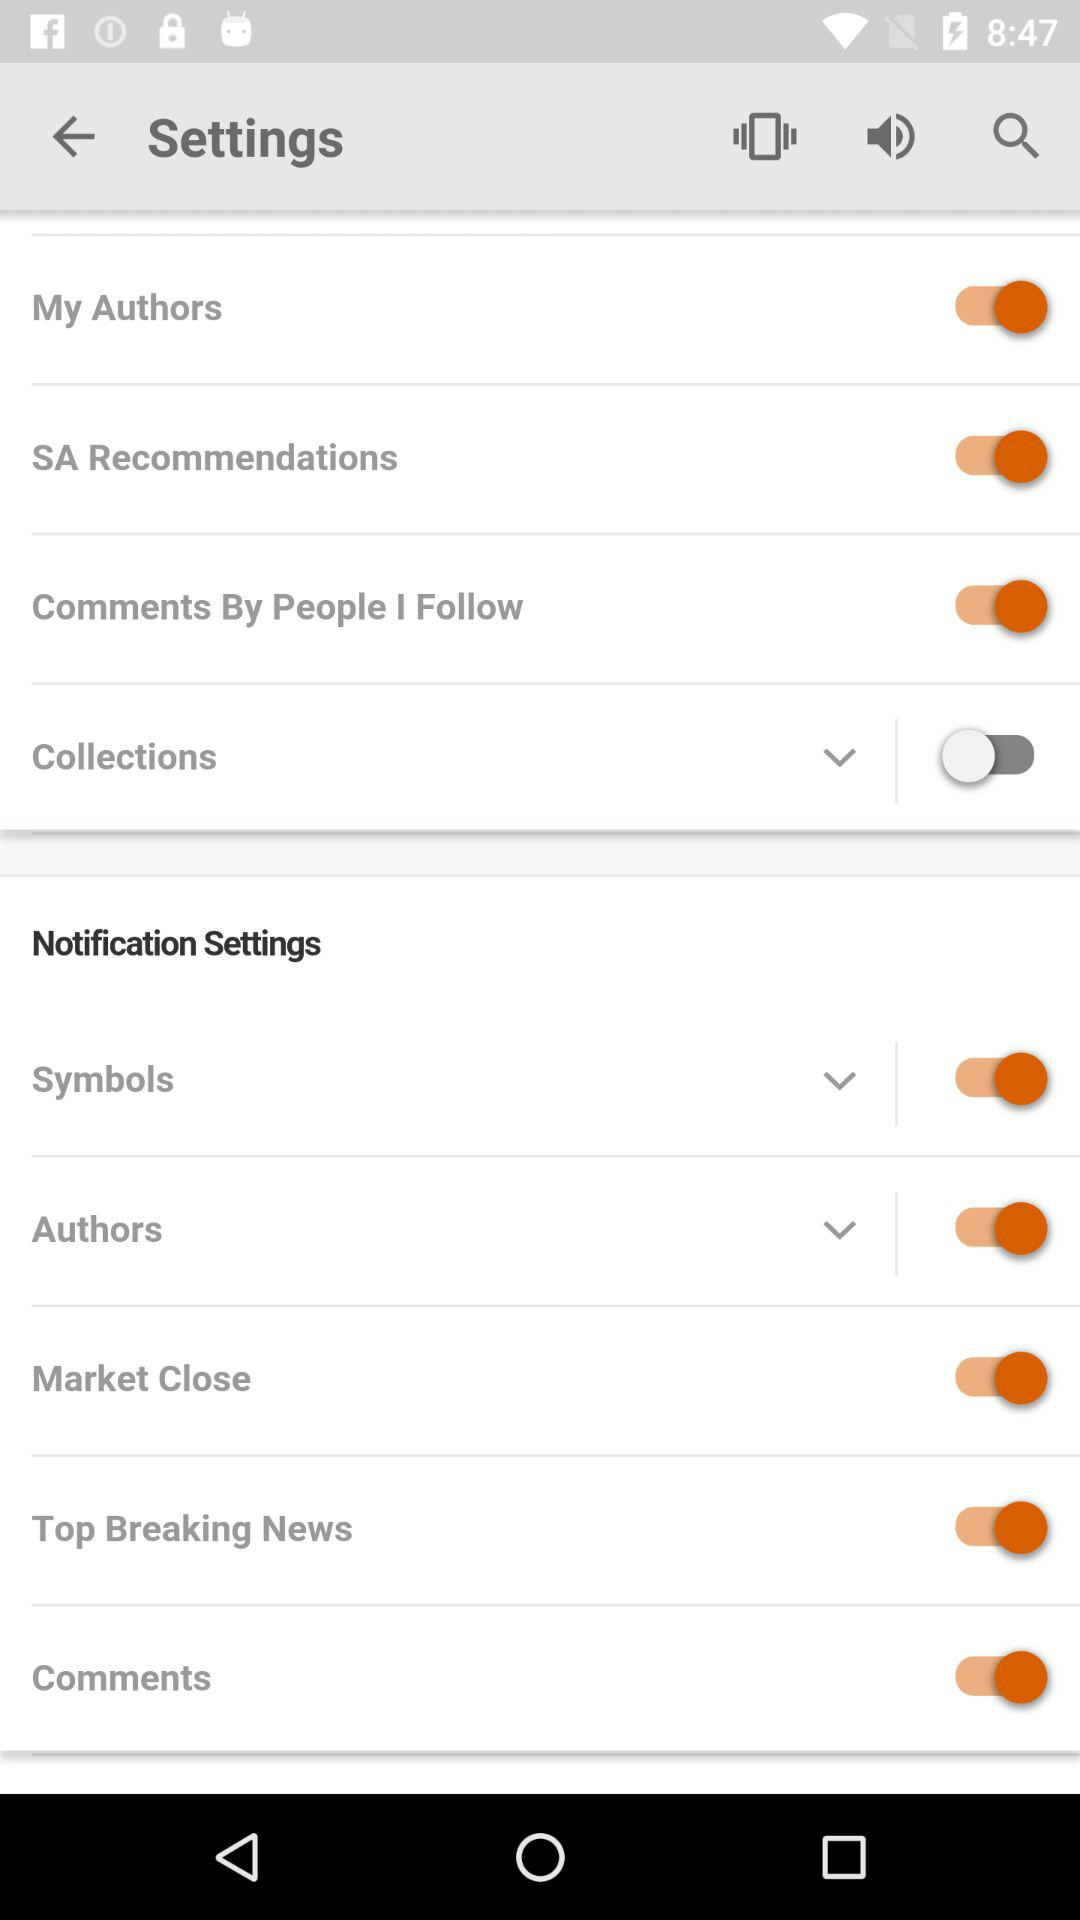What is the status of "Symbols" in the "Notification Settings"? The status of "Symbols" in the "Notification Settings" is "on". 